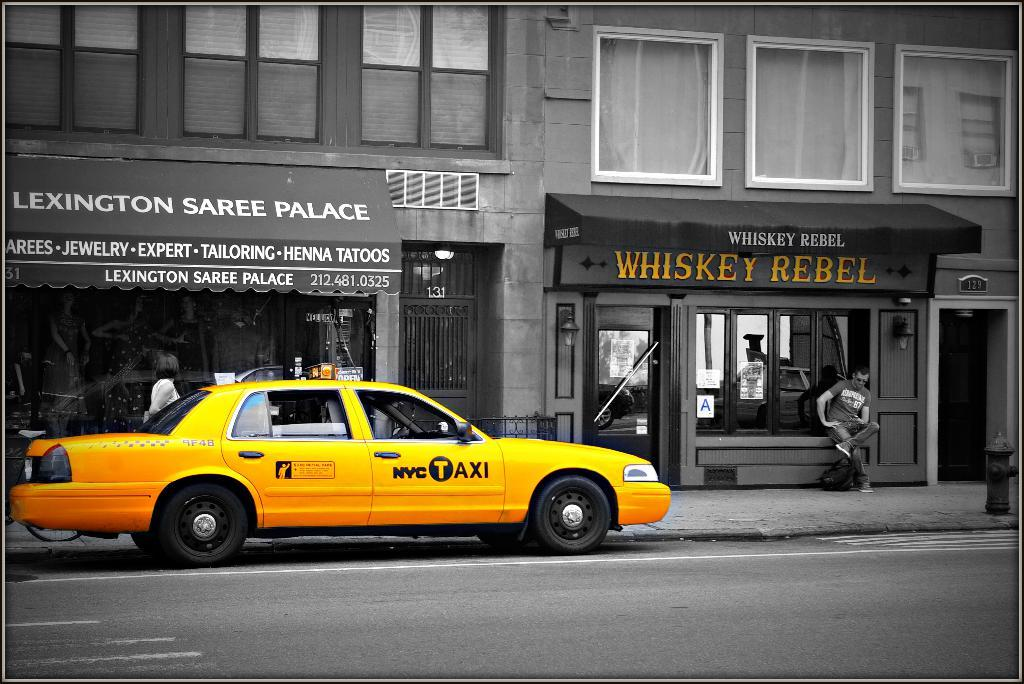<image>
Create a compact narrative representing the image presented. The Whiskey Rebel has a black awning over its front door. 